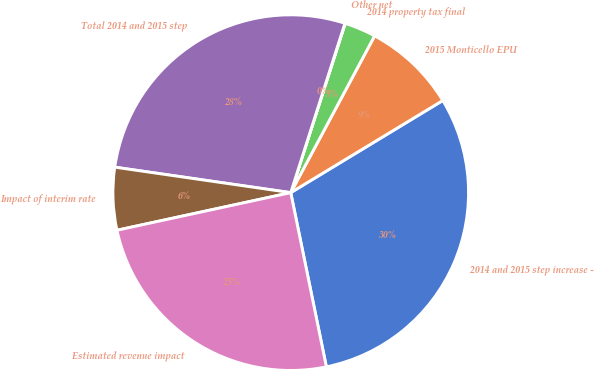Convert chart. <chart><loc_0><loc_0><loc_500><loc_500><pie_chart><fcel>2014 and 2015 step increase -<fcel>2015 Monticello EPU<fcel>2014 property tax final<fcel>Other net<fcel>Total 2014 and 2015 step<fcel>Impact of interim rate<fcel>Estimated revenue impact<nl><fcel>30.46%<fcel>8.51%<fcel>2.86%<fcel>0.03%<fcel>27.64%<fcel>5.68%<fcel>24.82%<nl></chart> 